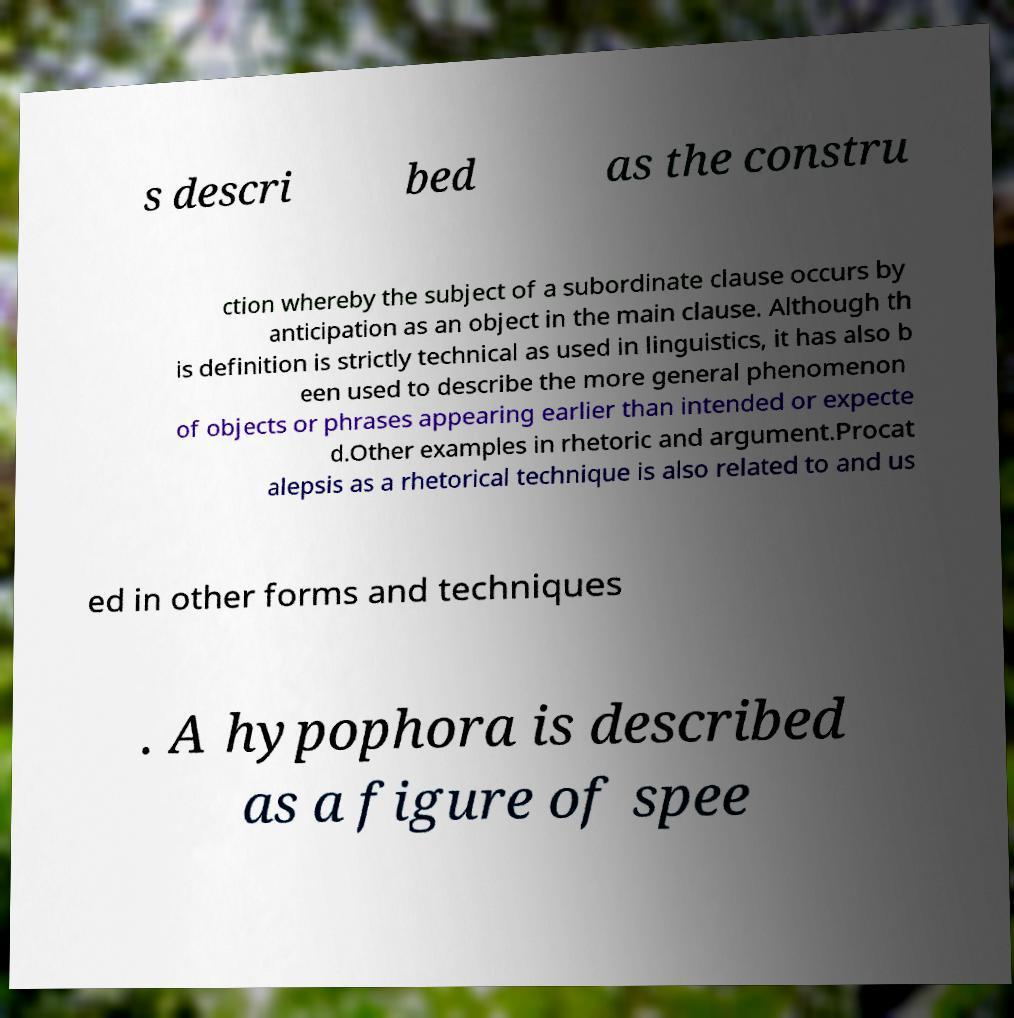Please read and relay the text visible in this image. What does it say? s descri bed as the constru ction whereby the subject of a subordinate clause occurs by anticipation as an object in the main clause. Although th is definition is strictly technical as used in linguistics, it has also b een used to describe the more general phenomenon of objects or phrases appearing earlier than intended or expecte d.Other examples in rhetoric and argument.Procat alepsis as a rhetorical technique is also related to and us ed in other forms and techniques . A hypophora is described as a figure of spee 